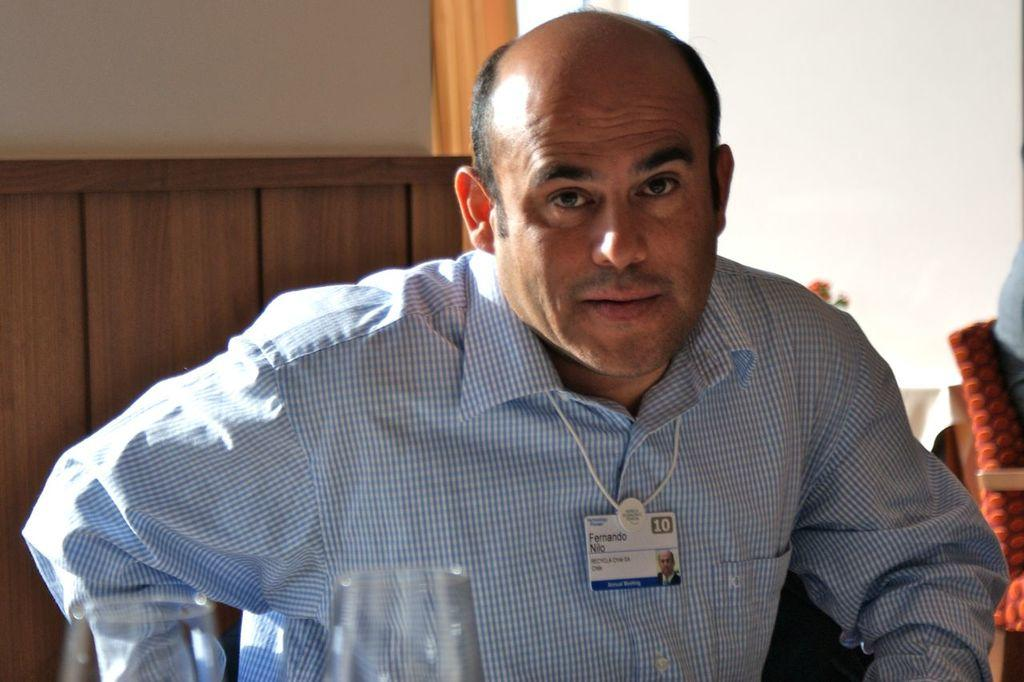Who is the main subject in the image? There is a man in the image. What is the man doing in the image? The man is posing for a camera. Can you describe any accessories the man is wearing? The man is wearing an ID card. What other objects can be seen in the image? There are glasses and a chair in the image. What is the color of the background in the image? The background of the image is white. What type of insurance does the man have, as seen in the image? There is no information about the man's insurance in the image. The image only shows the man posing for a camera, wearing an ID card, and standing near glasses and a chair with a white background. 